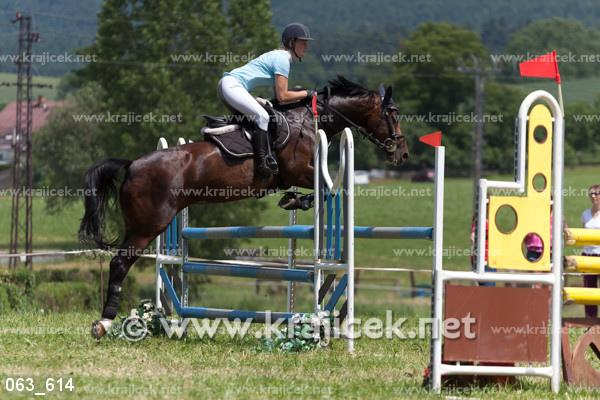What is this horse practicing? Please explain your reasoning. steeplechase. The horse is jumping over the barrier. 